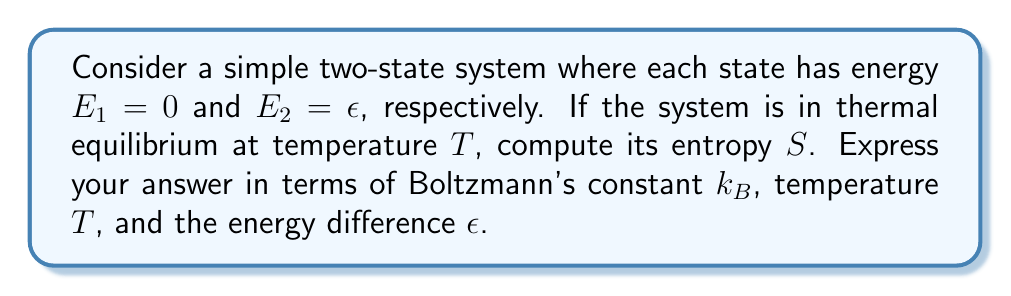Show me your answer to this math problem. Let's approach this step-by-step:

1) In statistical mechanics, the entropy $S$ is given by Boltzmann's formula:

   $$S = k_B \ln \Omega$$

   where $\Omega$ is the number of microstates.

2) For a two-state system, we need to use the partition function $Z$:

   $$Z = e^{-\beta E_1} + e^{-\beta E_2} = 1 + e^{-\beta \epsilon}$$

   where $\beta = \frac{1}{k_B T}$

3) The probability of being in each state is:

   $$p_1 = \frac{e^{-\beta E_1}}{Z} = \frac{1}{1 + e^{-\beta \epsilon}}$$
   
   $$p_2 = \frac{e^{-\beta E_2}}{Z} = \frac{e^{-\beta \epsilon}}{1 + e^{-\beta \epsilon}}$$

4) The entropy can be calculated using the Gibbs entropy formula:

   $$S = -k_B \sum_i p_i \ln p_i$$

5) Substituting the probabilities:

   $$S = -k_B \left(\frac{1}{1 + e^{-\beta \epsilon}} \ln \frac{1}{1 + e^{-\beta \epsilon}} + \frac{e^{-\beta \epsilon}}{1 + e^{-\beta \epsilon}} \ln \frac{e^{-\beta \epsilon}}{1 + e^{-\beta \epsilon}}\right)$$

6) Simplifying:

   $$S = k_B \ln(1 + e^{-\beta \epsilon}) + \frac{k_B \beta \epsilon e^{-\beta \epsilon}}{1 + e^{-\beta \epsilon}}$$

7) Substituting back $\beta = \frac{1}{k_B T}$:

   $$S = k_B \ln\left(1 + e^{-\frac{\epsilon}{k_B T}}\right) + \frac{\epsilon e^{-\frac{\epsilon}{k_B T}}}{T(1 + e^{-\frac{\epsilon}{k_B T}})}$$

This is the final expression for the entropy of the two-state system.
Answer: $S = k_B \ln\left(1 + e^{-\frac{\epsilon}{k_B T}}\right) + \frac{\epsilon e^{-\frac{\epsilon}{k_B T}}}{T(1 + e^{-\frac{\epsilon}{k_B T}})}$ 